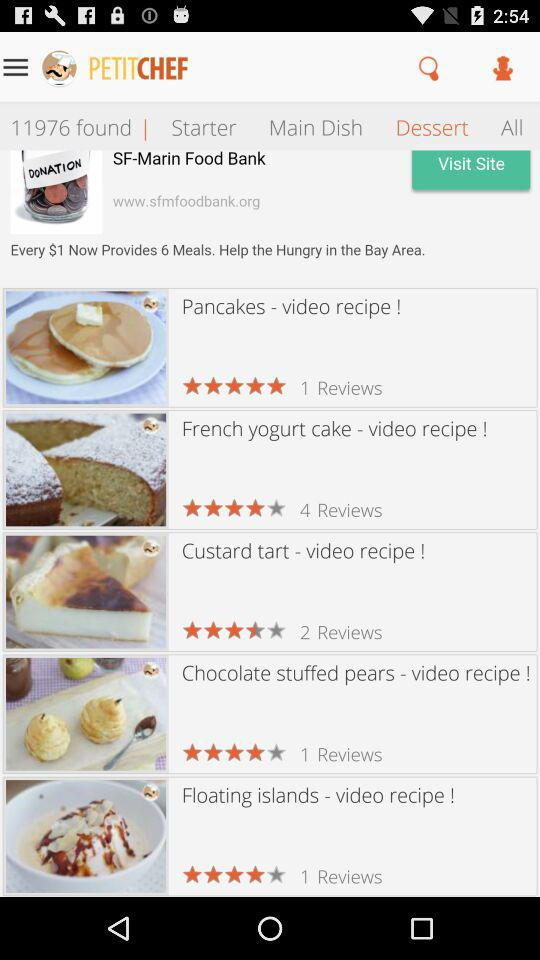What is the rating of the French yogurt cake? The rating of the French yogurt cake is 4 stars. 